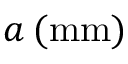<formula> <loc_0><loc_0><loc_500><loc_500>a \, ( m m )</formula> 